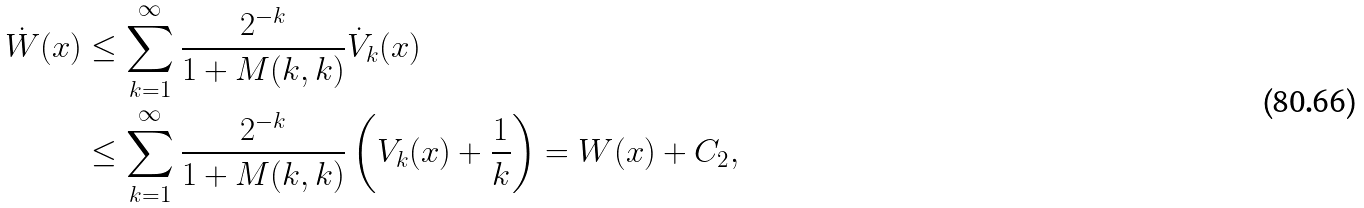<formula> <loc_0><loc_0><loc_500><loc_500>\dot { W } ( x ) & \leq \sum _ { k = 1 } ^ { \infty } \frac { 2 ^ { - k } } { 1 + M ( k , k ) } \dot { V } _ { k } ( x ) \\ & \leq \sum _ { k = 1 } ^ { \infty } \frac { 2 ^ { - k } } { 1 + M ( k , k ) } \left ( V _ { k } ( x ) + \frac { 1 } { k } \right ) = W ( x ) + C _ { 2 } ,</formula> 